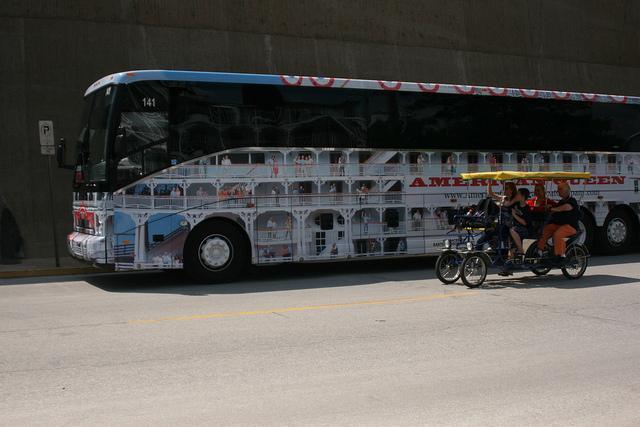Is this affirmation: "The bicycle is in front of the bus." correct?
Answer yes or no. No. 